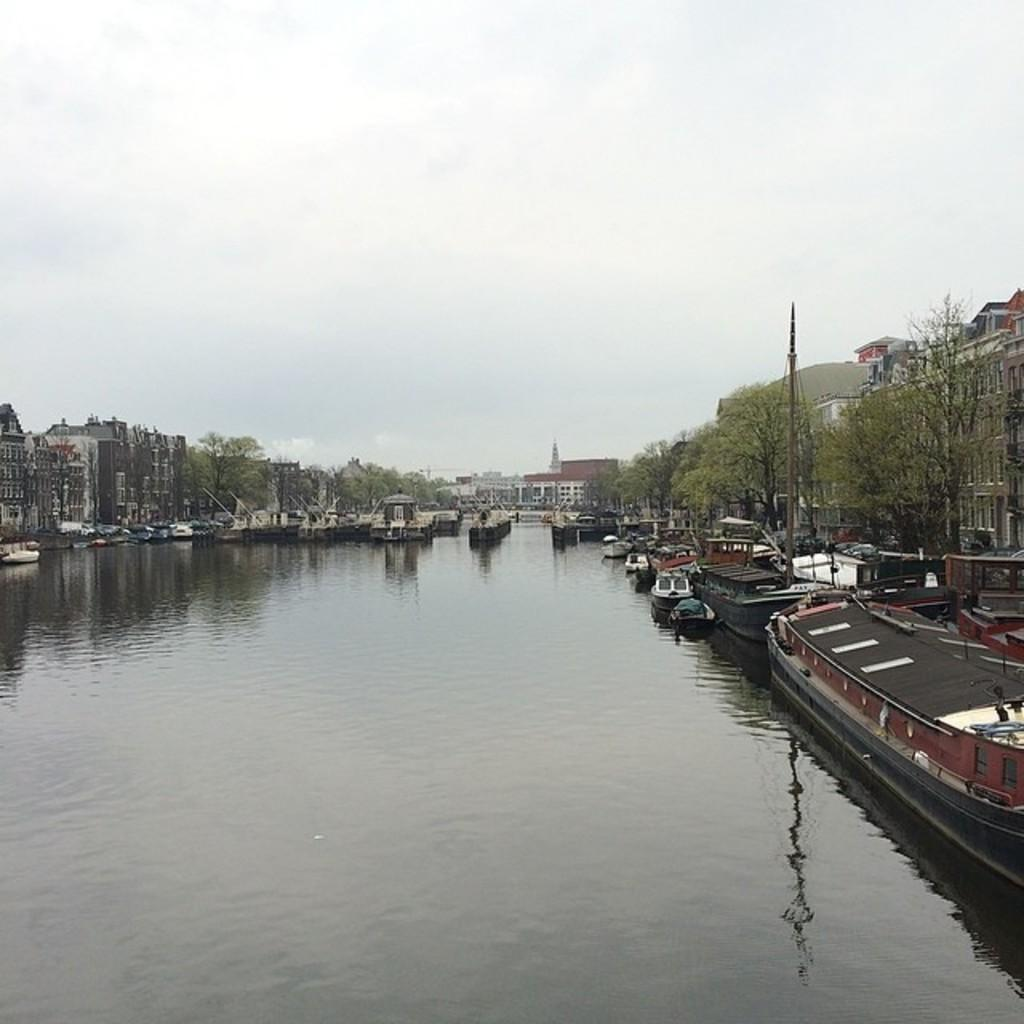What is in the water in the image? There are boats in the water in the image. What structure can be seen in the image? There is a pole with cables in the image. What can be seen in the background of the image? There is a group of trees, buildings with windows, and the sky visible in the background. Where is the grandmother sitting in the image? There is no grandmother present in the image. What shape is the window in the image? There is no window present in the image. 